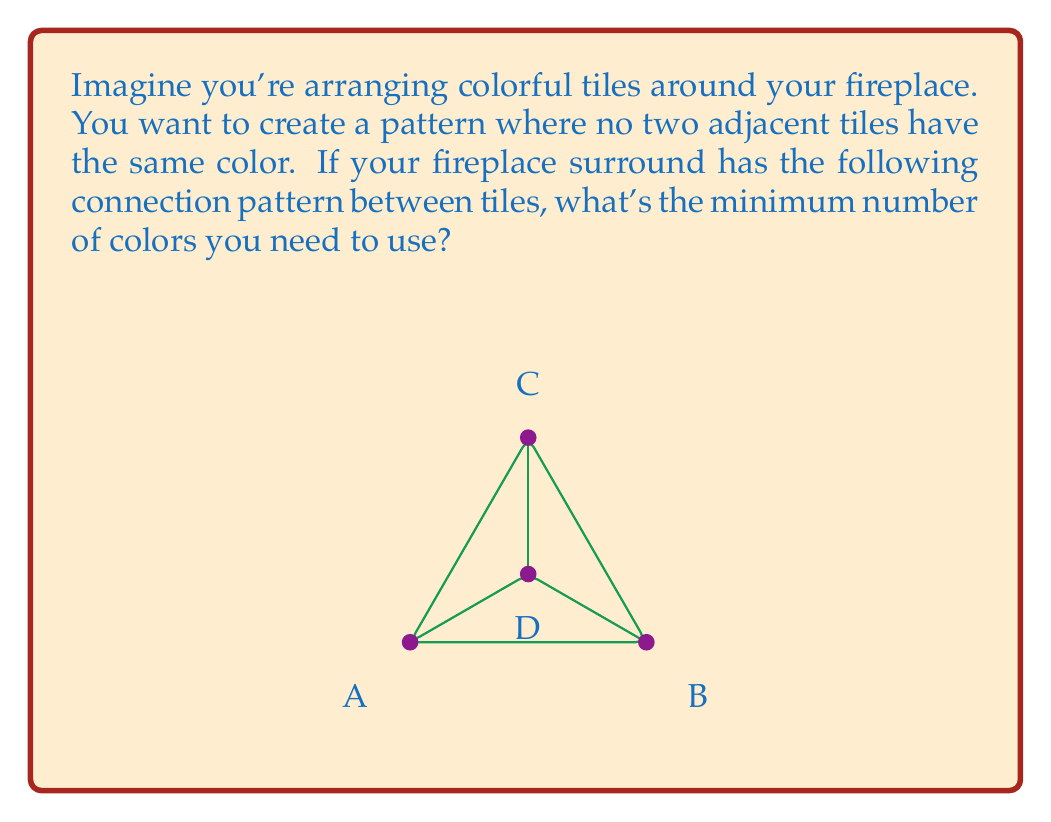Provide a solution to this math problem. To solve this problem, we need to find the chromatic number of the given graph. The chromatic number is the minimum number of colors needed to color a graph such that no two adjacent vertices have the same color. Let's approach this step-by-step:

1) First, let's identify the structure of the graph:
   - It has 4 vertices (A, B, C, and D)
   - Every vertex is connected to every other vertex

2) This type of graph, where every vertex is connected to every other vertex, is called a complete graph. For a complete graph with n vertices, it's denoted as $K_n$. In this case, we have $K_4$.

3) For a complete graph $K_n$, the chromatic number is always n. This is because each vertex must have a different color from all others, as it's connected to all of them.

4) In our case, n = 4, so we need 4 colors.

5) To verify, let's try to color it:
   - Assign color 1 to A
   - B is connected to A, so it needs a different color. Assign color 2 to B.
   - C is connected to both A and B, so it needs a third color. Assign color 3 to C.
   - D is connected to A, B, and C, so it needs a fourth color. Assign color 4 to D.

6) We've used 4 colors, and it's impossible to use fewer because each vertex needs a unique color.

Therefore, the chromatic number of this graph is 4.
Answer: The minimum number of colors needed is 4. 